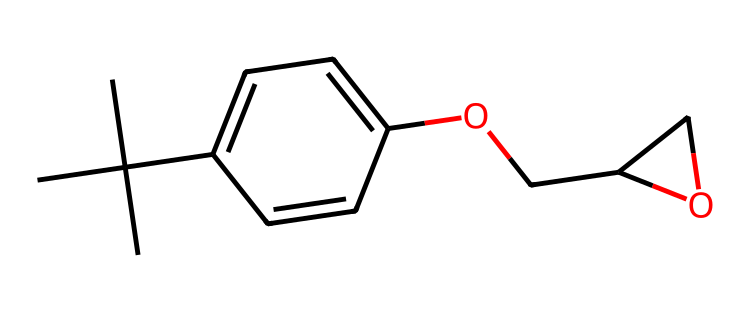What is the total number of carbon atoms in this chemical? By inspecting the SMILES representation, we can count the carbon atoms represented by 'C'. In the structure, there are 15 carbon atoms total.
Answer: 15 How many oxygen atoms are present in this compound? The SMILES structure shows two occurrences of 'O', which indicates two oxygen atoms are present in the molecule.
Answer: 2 What functional group is indicated by the presence of 'OCC'? The 'OCC' portion of the SMILES suggests an ether functional group being present here, as it connects through an oxygen atom to develop a longer carbon chain.
Answer: ether Does the compound contain any rings in its structure? The structure contains a benzene ring, indicated by the 'c' and 'cc' notation in the SMILES representation, which denotes double bonds typical of aromatic compounds.
Answer: yes What type of polymerizable group does this epoxy-based photoresist contain, indicated by the presence of epoxy? The presence of an epoxide group (noted by the connection around the oxygen atom, creating a three-membered ring) signifies that it's an epoxy-based photoresist.
Answer: epoxide Which parts of the molecule contribute to its cross-linking behavior in photoresist applications? The epoxy groups in the structure are responsible for enabling cross-linking when exposed to UV light, facilitating the photoresist properties necessary for circuit board applications.
Answer: epoxy groups How can this compound interact with UV light during the lithography process? The specific arrangement of the functional groups, especially the presence of the epoxy group, allows it to undergo a photochemical reaction when exposed to UV light, facilitating the development of patterns in photolithography.
Answer: photochemical reaction 